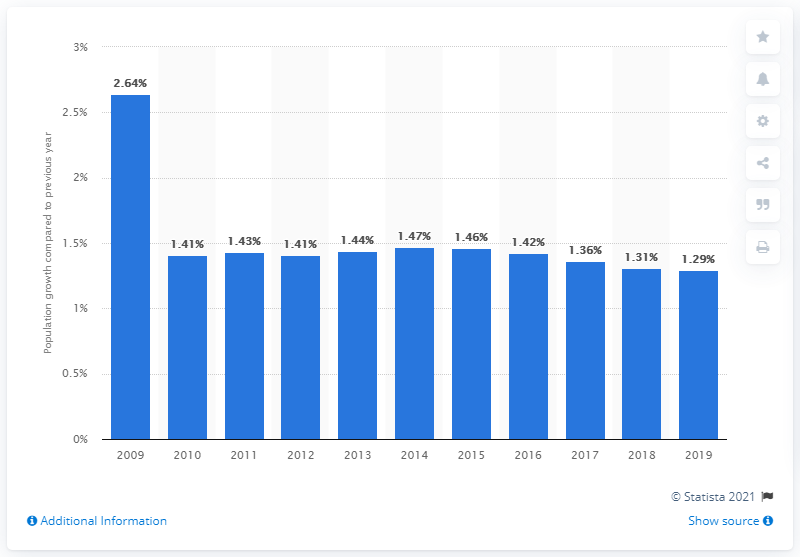List a handful of essential elements in this visual. Kazakhstan's population increased by 1.29% in 2019, according to the latest estimates. 